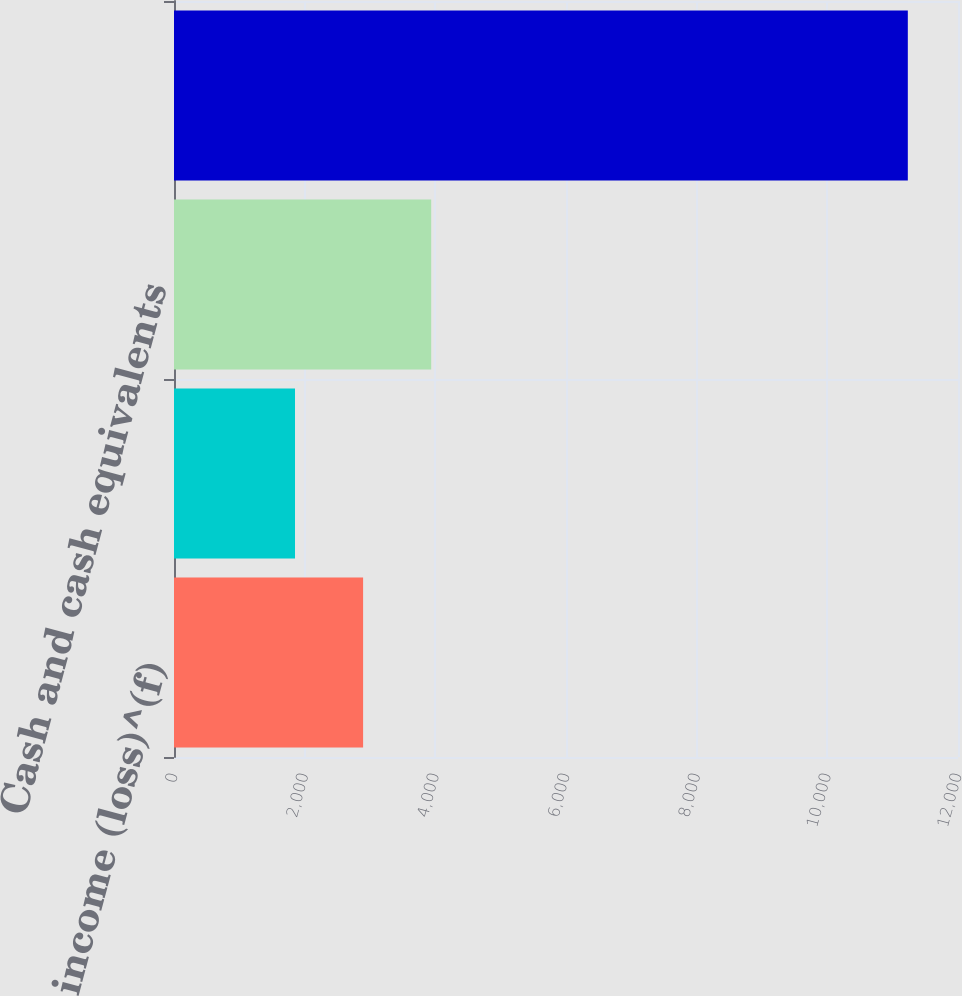Convert chart to OTSL. <chart><loc_0><loc_0><loc_500><loc_500><bar_chart><fcel>Operating income (loss)^(f)<fcel>Shares used to compute<fcel>Cash and cash equivalents<fcel>Total assets^(f)<nl><fcel>2894.4<fcel>1852.2<fcel>3936.6<fcel>11232<nl></chart> 